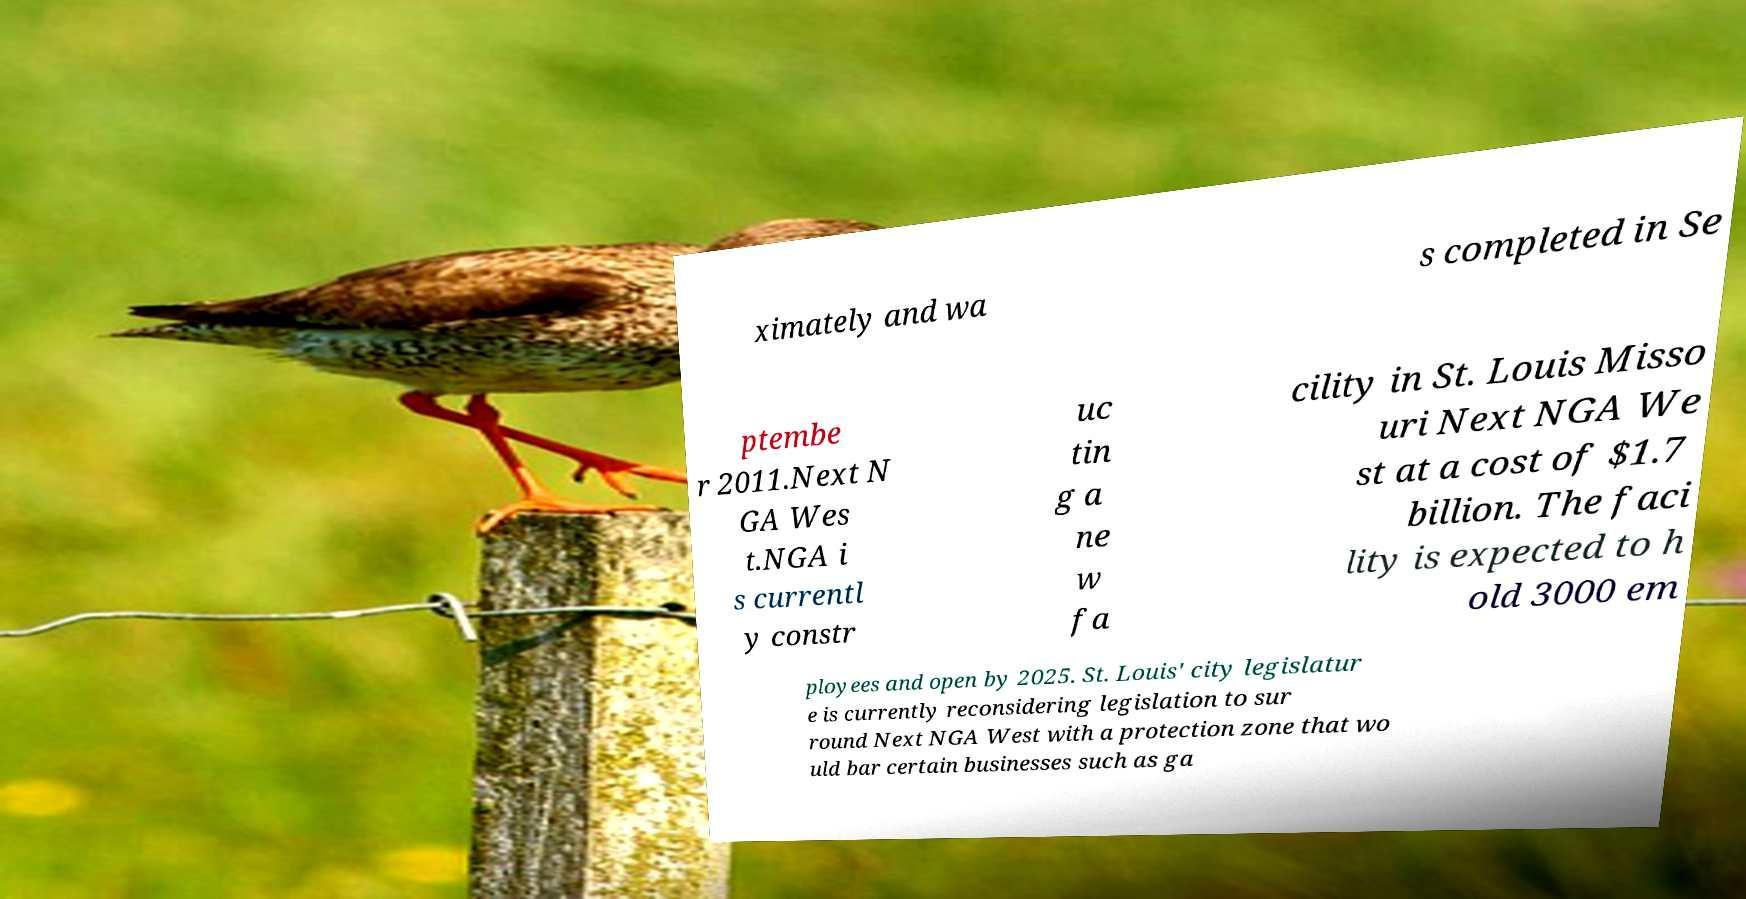Can you accurately transcribe the text from the provided image for me? ximately and wa s completed in Se ptembe r 2011.Next N GA Wes t.NGA i s currentl y constr uc tin g a ne w fa cility in St. Louis Misso uri Next NGA We st at a cost of $1.7 billion. The faci lity is expected to h old 3000 em ployees and open by 2025. St. Louis' city legislatur e is currently reconsidering legislation to sur round Next NGA West with a protection zone that wo uld bar certain businesses such as ga 